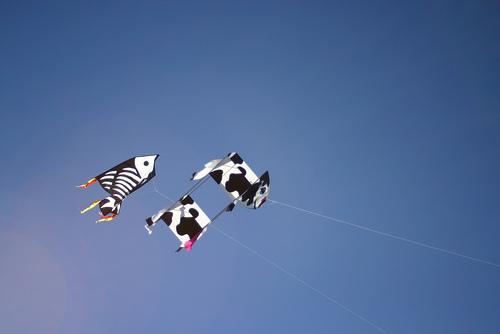What animal pattern is the two piece kite using?

Choices:
A) cow
B) jaguar
C) zebra
D) leopard cow 